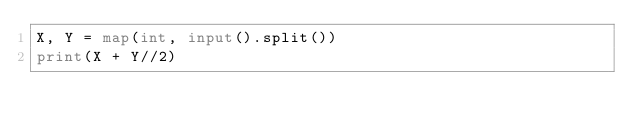<code> <loc_0><loc_0><loc_500><loc_500><_Python_>X, Y = map(int, input().split())
print(X + Y//2)
</code> 